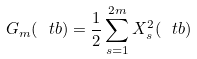<formula> <loc_0><loc_0><loc_500><loc_500>G _ { m } ( \ t b ) = \frac { 1 } { 2 } \sum _ { s = 1 } ^ { 2 m } X _ { s } ^ { 2 } ( \ t b )</formula> 